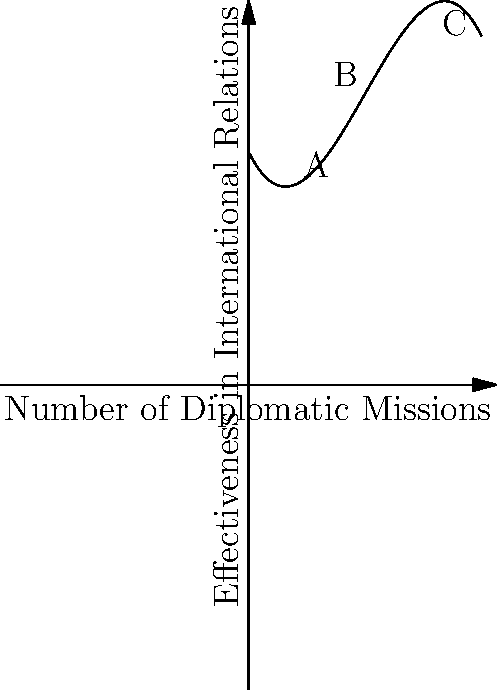Consider the polynomial graph representing the relationship between the number of diplomatic missions and their effectiveness in fostering international relations. At which point does the graph indicate the optimal number of diplomatic missions for maximum effectiveness? To determine the optimal number of diplomatic missions for maximum effectiveness, we need to analyze the graph:

1. The y-axis represents the effectiveness in international relations, while the x-axis represents the number of diplomatic missions.

2. The graph is a cubic polynomial function, which means it has one global maximum or minimum point.

3. We can observe that the graph increases from the origin, reaches a peak, and then starts to decrease.

4. The peak of the graph represents the point of maximum effectiveness.

5. Among the labeled points, point B appears to be closest to this peak.

6. Point B corresponds to approximately 5 diplomatic missions on the x-axis.

7. This suggests that around 5 diplomatic missions provide the optimal balance for maximum effectiveness in fostering international relations.

8. Beyond this point, the effectiveness starts to decline, possibly due to factors such as increased complexity in coordination or resource allocation.
Answer: Point B (approximately 5 diplomatic missions) 